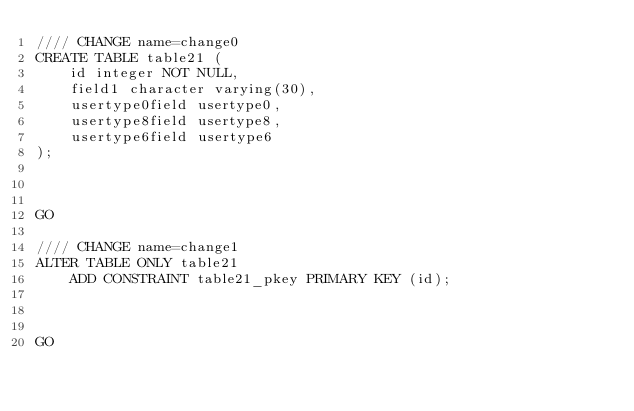<code> <loc_0><loc_0><loc_500><loc_500><_SQL_>//// CHANGE name=change0
CREATE TABLE table21 (
    id integer NOT NULL,
    field1 character varying(30),
    usertype0field usertype0,
    usertype8field usertype8,
    usertype6field usertype6
);



GO

//// CHANGE name=change1
ALTER TABLE ONLY table21
    ADD CONSTRAINT table21_pkey PRIMARY KEY (id);



GO
</code> 